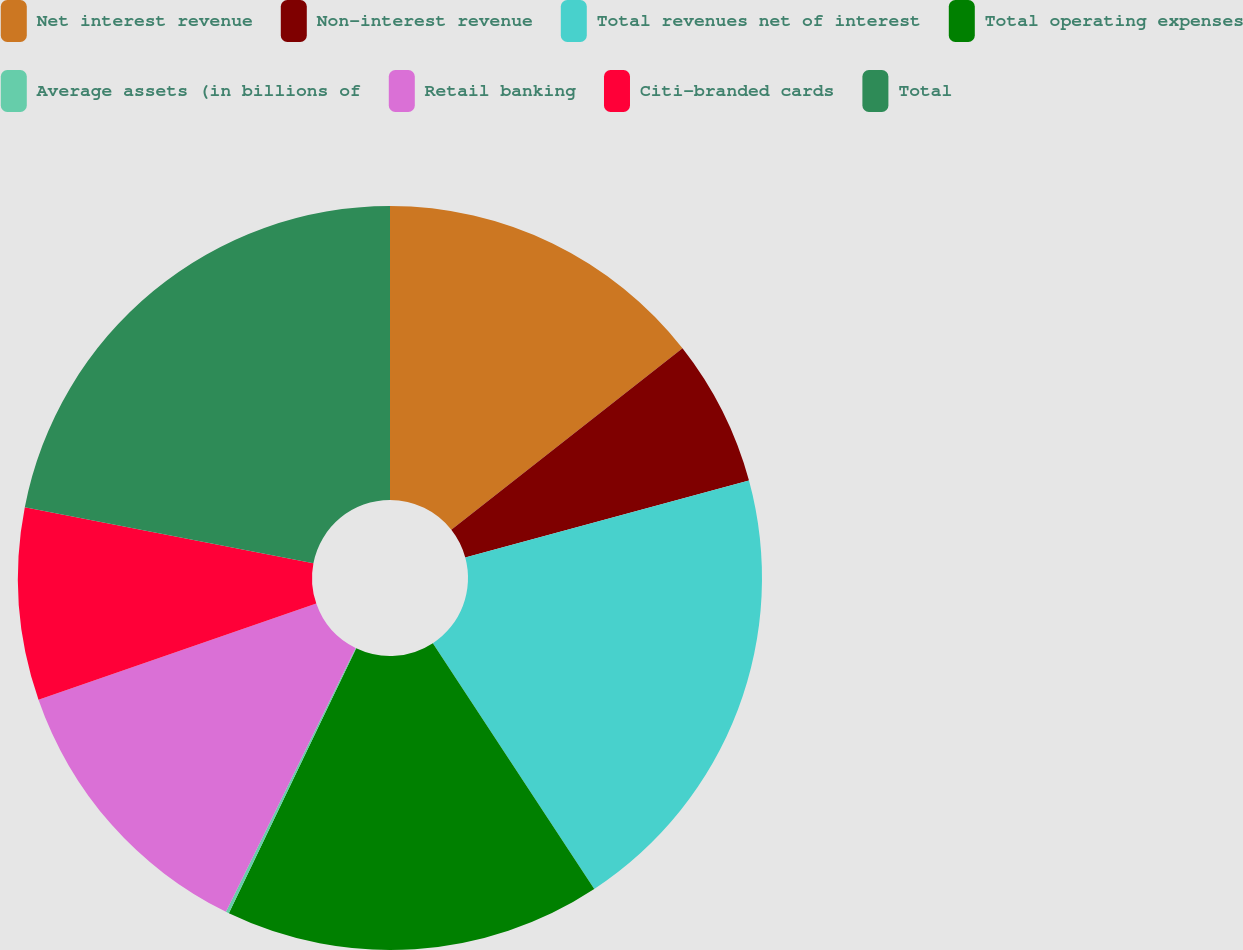Convert chart. <chart><loc_0><loc_0><loc_500><loc_500><pie_chart><fcel>Net interest revenue<fcel>Non-interest revenue<fcel>Total revenues net of interest<fcel>Total operating expenses<fcel>Average assets (in billions of<fcel>Retail banking<fcel>Citi-branded cards<fcel>Total<nl><fcel>14.4%<fcel>6.38%<fcel>19.97%<fcel>16.38%<fcel>0.14%<fcel>12.42%<fcel>8.36%<fcel>21.95%<nl></chart> 